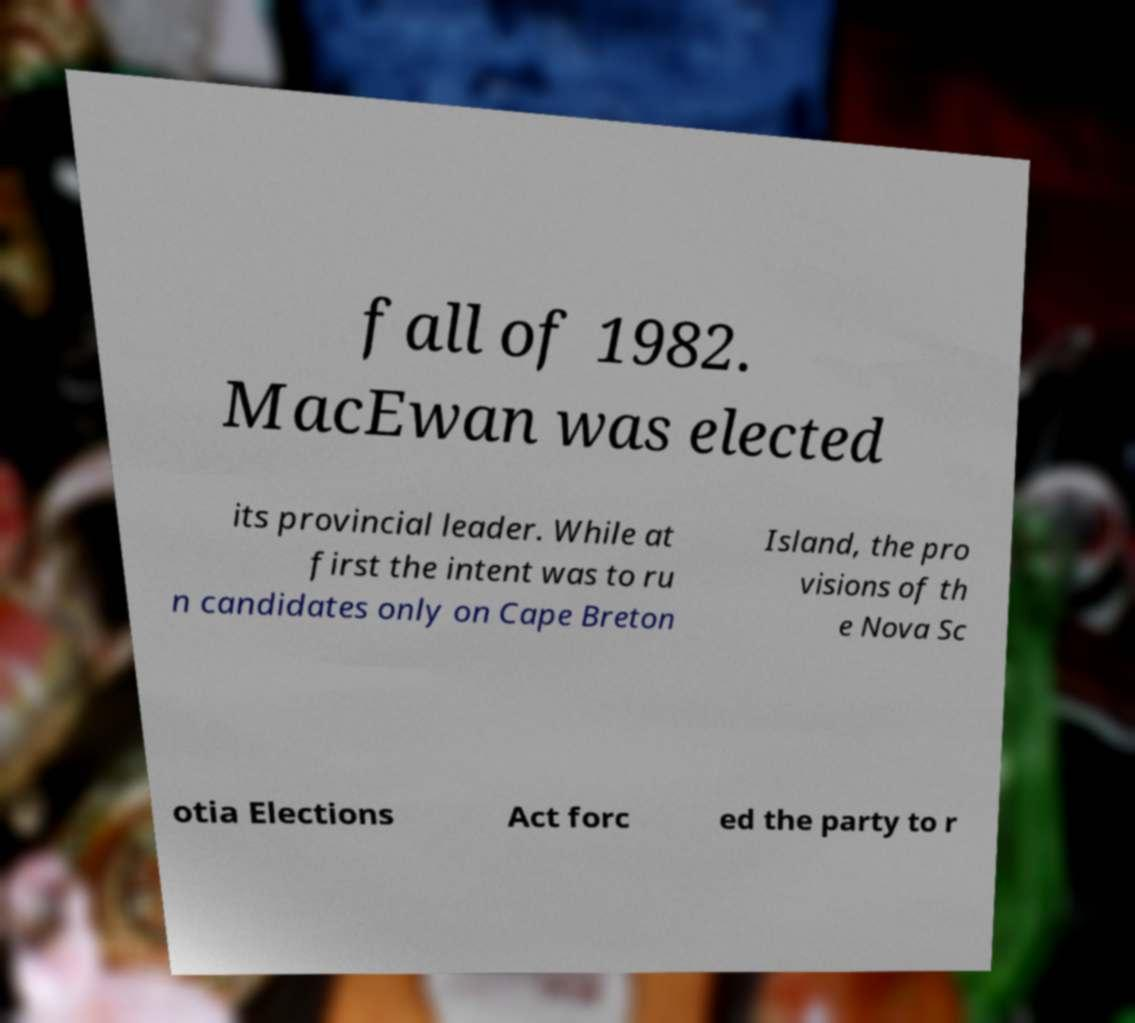Could you assist in decoding the text presented in this image and type it out clearly? fall of 1982. MacEwan was elected its provincial leader. While at first the intent was to ru n candidates only on Cape Breton Island, the pro visions of th e Nova Sc otia Elections Act forc ed the party to r 